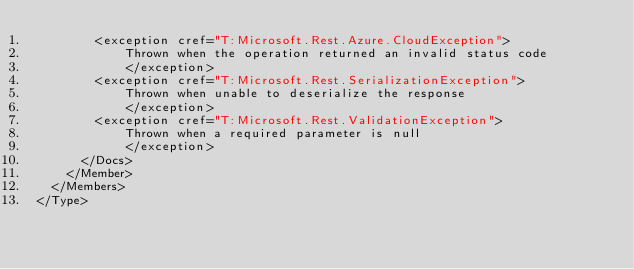<code> <loc_0><loc_0><loc_500><loc_500><_XML_>        <exception cref="T:Microsoft.Rest.Azure.CloudException">
            Thrown when the operation returned an invalid status code
            </exception>
        <exception cref="T:Microsoft.Rest.SerializationException">
            Thrown when unable to deserialize the response
            </exception>
        <exception cref="T:Microsoft.Rest.ValidationException">
            Thrown when a required parameter is null
            </exception>
      </Docs>
    </Member>
  </Members>
</Type>
</code> 